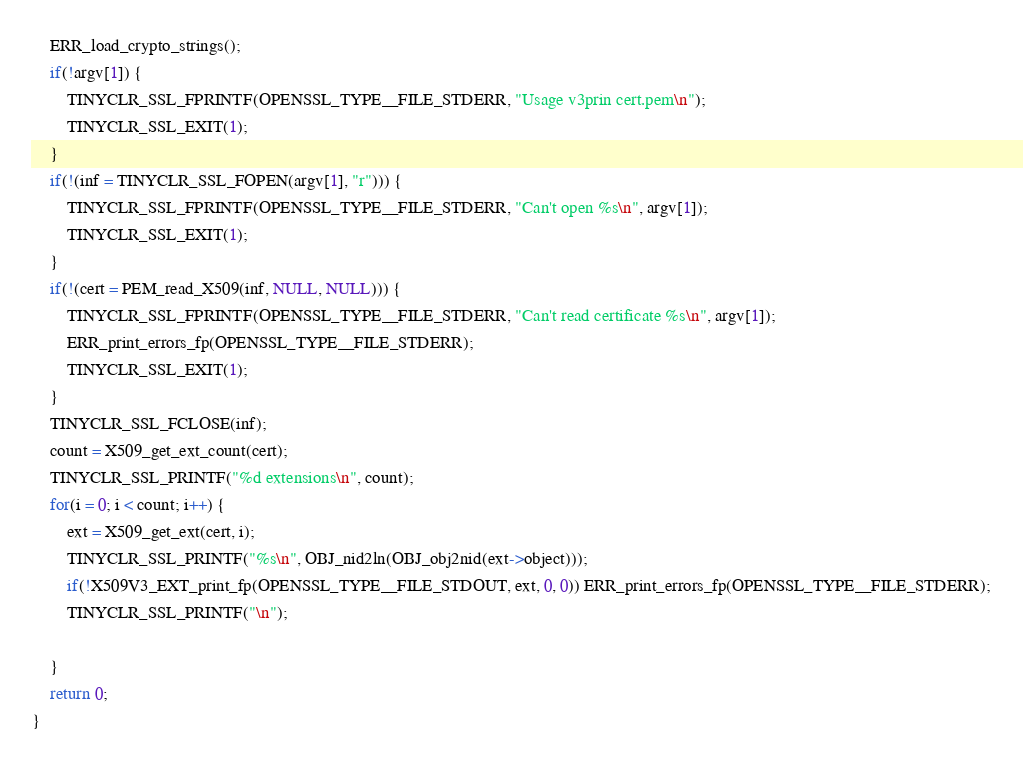Convert code to text. <code><loc_0><loc_0><loc_500><loc_500><_C++_>	ERR_load_crypto_strings();
	if(!argv[1]) {
		TINYCLR_SSL_FPRINTF(OPENSSL_TYPE__FILE_STDERR, "Usage v3prin cert.pem\n");
		TINYCLR_SSL_EXIT(1);
	}
	if(!(inf = TINYCLR_SSL_FOPEN(argv[1], "r"))) {
		TINYCLR_SSL_FPRINTF(OPENSSL_TYPE__FILE_STDERR, "Can't open %s\n", argv[1]);
		TINYCLR_SSL_EXIT(1);
	}
	if(!(cert = PEM_read_X509(inf, NULL, NULL))) {
		TINYCLR_SSL_FPRINTF(OPENSSL_TYPE__FILE_STDERR, "Can't read certificate %s\n", argv[1]);
		ERR_print_errors_fp(OPENSSL_TYPE__FILE_STDERR);
		TINYCLR_SSL_EXIT(1);
	}
	TINYCLR_SSL_FCLOSE(inf);
	count = X509_get_ext_count(cert);
	TINYCLR_SSL_PRINTF("%d extensions\n", count);
	for(i = 0; i < count; i++) {
		ext = X509_get_ext(cert, i);
		TINYCLR_SSL_PRINTF("%s\n", OBJ_nid2ln(OBJ_obj2nid(ext->object)));
		if(!X509V3_EXT_print_fp(OPENSSL_TYPE__FILE_STDOUT, ext, 0, 0)) ERR_print_errors_fp(OPENSSL_TYPE__FILE_STDERR);
		TINYCLR_SSL_PRINTF("\n");
		
	}
	return 0;
}
</code> 